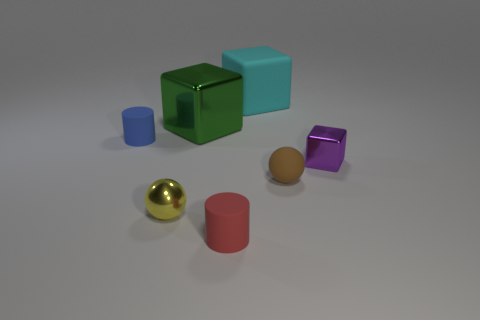There is a ball that is the same material as the big green cube; what is its color?
Offer a very short reply. Yellow. The rubber block has what color?
Provide a short and direct response. Cyan. Does the brown ball have the same material as the cube that is left of the cyan object?
Keep it short and to the point. No. What number of things are both in front of the cyan cube and on the left side of the brown rubber thing?
Offer a terse response. 4. What shape is the red object that is the same size as the yellow metal thing?
Your answer should be compact. Cylinder. Is there a tiny rubber ball that is left of the tiny blue rubber thing that is behind the cylinder on the right side of the tiny blue rubber object?
Your response must be concise. No. Does the matte ball have the same color as the matte cylinder that is in front of the tiny yellow thing?
Keep it short and to the point. No. What number of matte blocks have the same color as the tiny shiny sphere?
Your answer should be very brief. 0. There is a sphere left of the tiny red object that is in front of the tiny blue rubber cylinder; how big is it?
Keep it short and to the point. Small. What number of things are spheres to the left of the big cyan matte thing or cyan matte objects?
Make the answer very short. 2. 